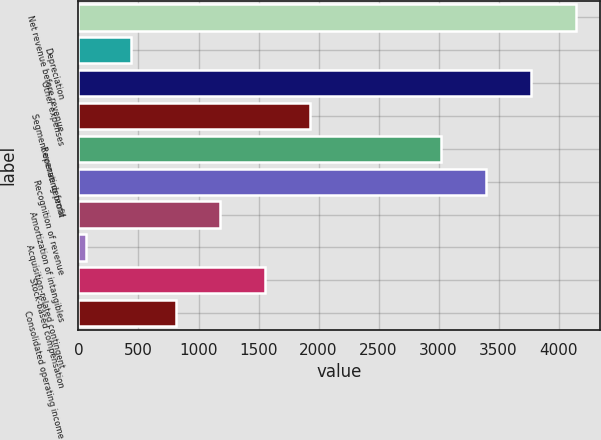Convert chart to OTSL. <chart><loc_0><loc_0><loc_500><loc_500><bar_chart><fcel>Net revenue before revenue<fcel>Depreciation<fcel>Other expenses<fcel>Segment operating profit<fcel>Revenue deferral<fcel>Recognition of revenue<fcel>Amortization of intangibles<fcel>Acquisition-related contingent<fcel>Stock-based compensation<fcel>Consolidated operating income<nl><fcel>4140.7<fcel>436.9<fcel>3767.8<fcel>1928.5<fcel>3022<fcel>3394.9<fcel>1182.7<fcel>64<fcel>1555.6<fcel>809.8<nl></chart> 